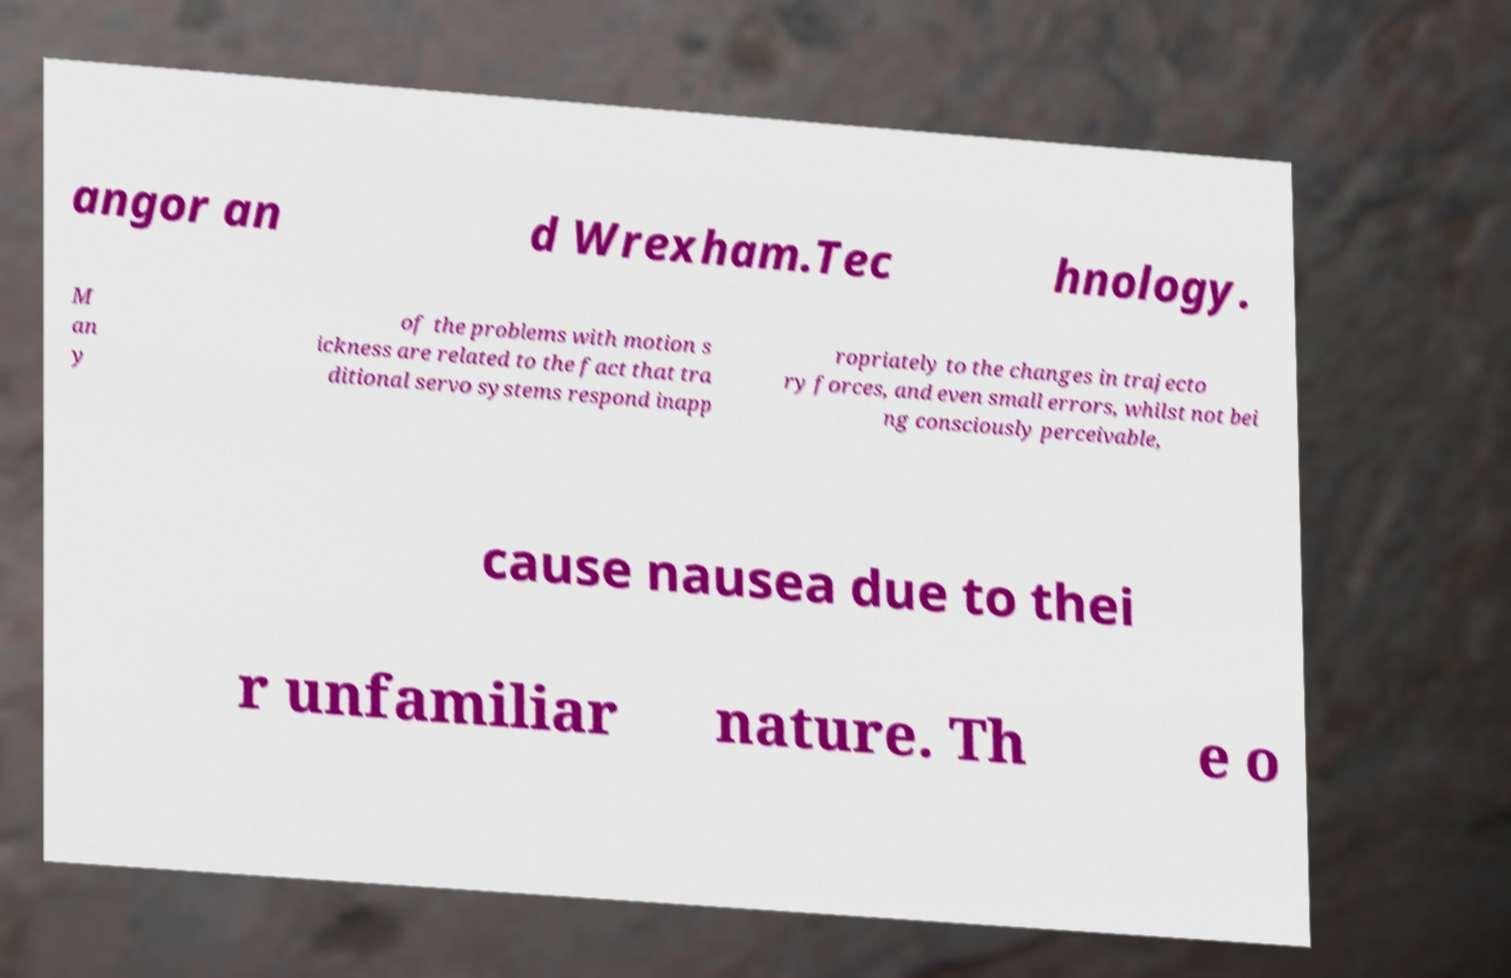Could you assist in decoding the text presented in this image and type it out clearly? angor an d Wrexham.Tec hnology. M an y of the problems with motion s ickness are related to the fact that tra ditional servo systems respond inapp ropriately to the changes in trajecto ry forces, and even small errors, whilst not bei ng consciously perceivable, cause nausea due to thei r unfamiliar nature. Th e o 